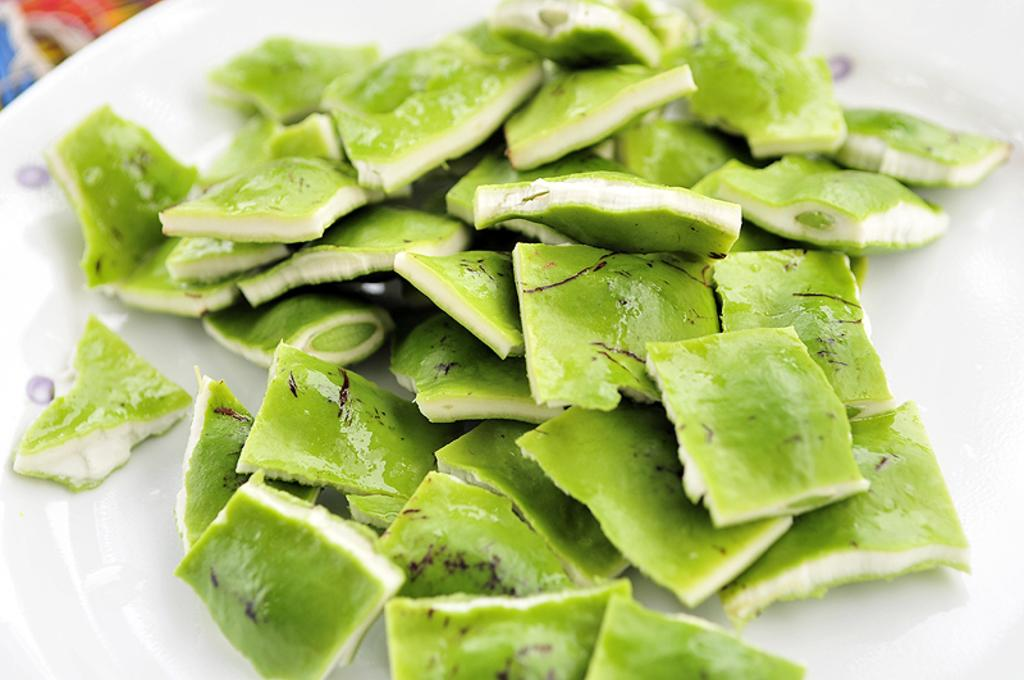What type of food can be seen on the plate in the image? There are cut vegetables on a plate in the image. What type of test is being conducted on the sidewalk in the image? There is no test or sidewalk present in the image; it only features a plate of cut vegetables. 